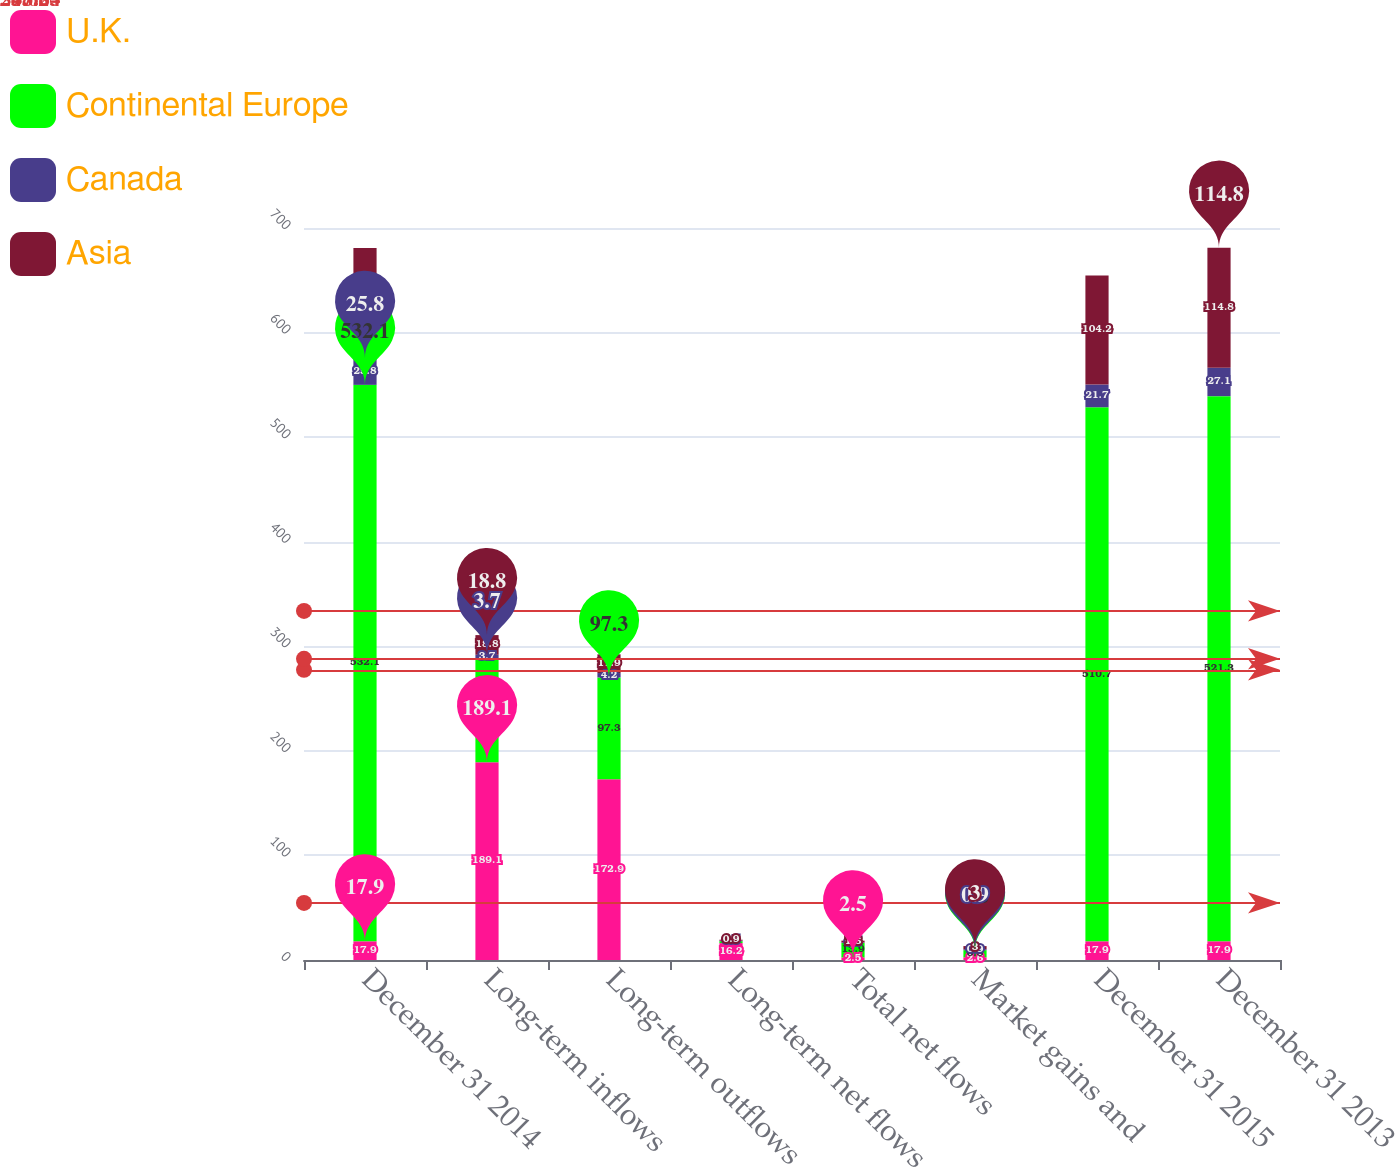Convert chart. <chart><loc_0><loc_0><loc_500><loc_500><stacked_bar_chart><ecel><fcel>December 31 2014<fcel>Long-term inflows<fcel>Long-term outflows<fcel>Long-term net flows<fcel>Total net flows<fcel>Market gains and<fcel>December 31 2015<fcel>December 31 2013<nl><fcel>U.K.<fcel>17.9<fcel>189.1<fcel>172.9<fcel>16.2<fcel>2.5<fcel>2.6<fcel>17.9<fcel>17.9<nl><fcel>Continental Europe<fcel>532.1<fcel>99.1<fcel>97.3<fcel>1.8<fcel>13.9<fcel>6.8<fcel>510.7<fcel>521.3<nl><fcel>Canada<fcel>25.8<fcel>3.7<fcel>4.2<fcel>0.5<fcel>0.5<fcel>0.9<fcel>21.7<fcel>27.1<nl><fcel>Asia<fcel>105.1<fcel>18.8<fcel>17.9<fcel>0.9<fcel>1.6<fcel>3<fcel>104.2<fcel>114.8<nl></chart> 